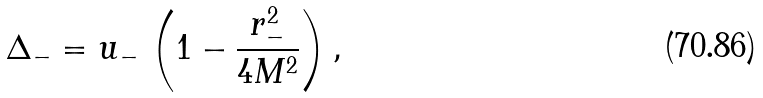Convert formula to latex. <formula><loc_0><loc_0><loc_500><loc_500>\Delta _ { - } = u _ { - } \, \left ( 1 - \frac { r _ { - } ^ { 2 } } { 4 M ^ { 2 } } \right ) ,</formula> 